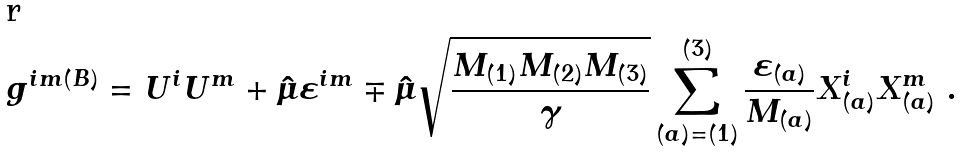<formula> <loc_0><loc_0><loc_500><loc_500>g ^ { i m ( B ) } = U ^ { i } U ^ { m } + \hat { \mu } \varepsilon ^ { i m } \mp \hat { \mu } \sqrt { \frac { M _ { ( 1 ) } M _ { ( 2 ) } M _ { ( 3 ) } } { \gamma } } \sum _ { ( a ) = ( 1 ) } ^ { ( 3 ) } \frac { \varepsilon _ { ( a ) } } { M _ { ( a ) } } X ^ { i } _ { ( a ) } X ^ { m } _ { ( a ) } \ .</formula> 